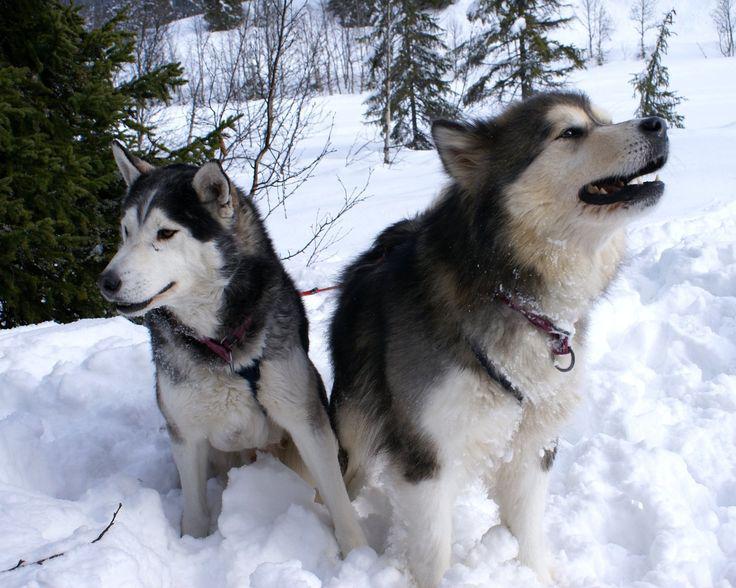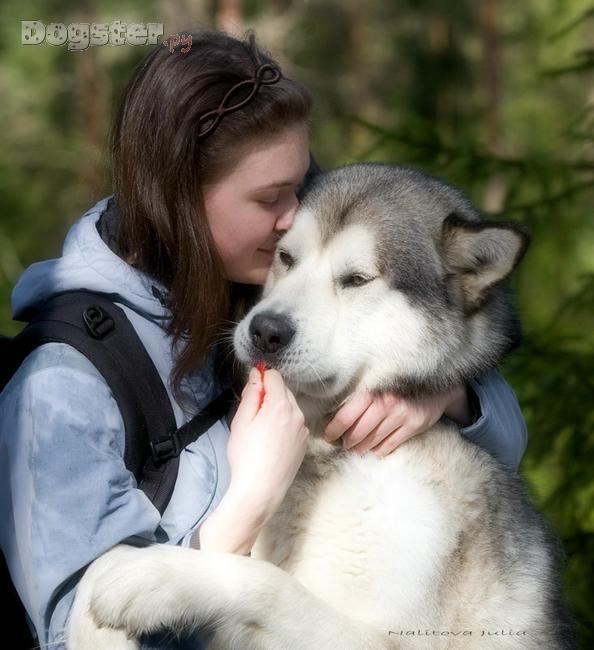The first image is the image on the left, the second image is the image on the right. For the images shown, is this caption "The left image includes two huskies side-by-side on snowy ground, and the right image includes one woman with at least one husky." true? Answer yes or no. Yes. The first image is the image on the left, the second image is the image on the right. For the images displayed, is the sentence "There are more dogs in the image on the left." factually correct? Answer yes or no. Yes. 